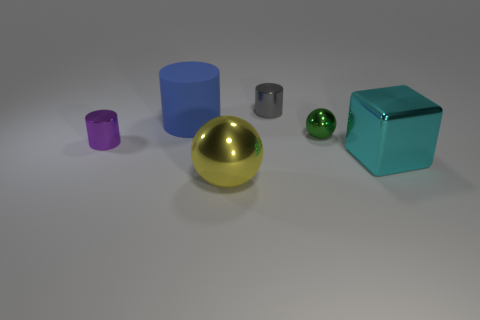Subtract 1 cylinders. How many cylinders are left? 2 Subtract all tiny gray shiny cylinders. How many cylinders are left? 2 Add 3 big balls. How many objects exist? 9 Subtract all balls. How many objects are left? 4 Subtract all small green metal spheres. Subtract all large blue shiny cylinders. How many objects are left? 5 Add 3 small metallic things. How many small metallic things are left? 6 Add 5 green spheres. How many green spheres exist? 6 Subtract 1 cyan blocks. How many objects are left? 5 Subtract all cyan cylinders. Subtract all purple cubes. How many cylinders are left? 3 